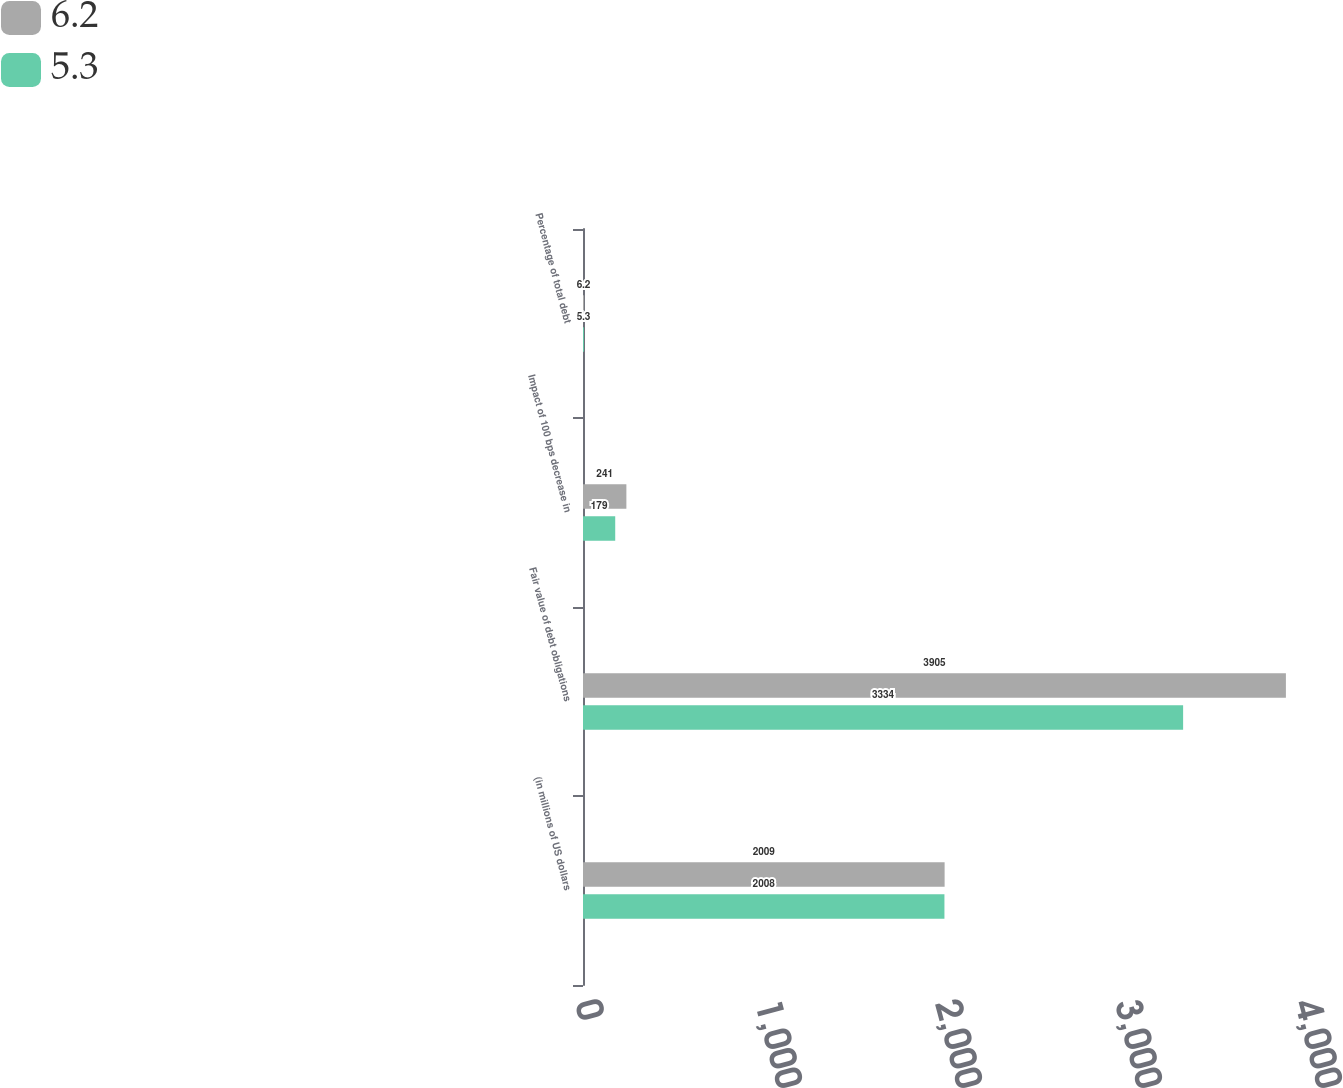Convert chart. <chart><loc_0><loc_0><loc_500><loc_500><stacked_bar_chart><ecel><fcel>(in millions of US dollars<fcel>Fair value of debt obligations<fcel>Impact of 100 bps decrease in<fcel>Percentage of total debt<nl><fcel>6.2<fcel>2009<fcel>3905<fcel>241<fcel>6.2<nl><fcel>5.3<fcel>2008<fcel>3334<fcel>179<fcel>5.3<nl></chart> 